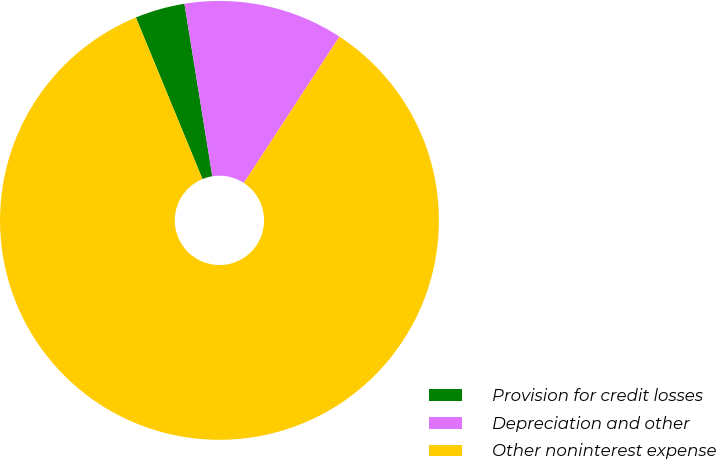Convert chart. <chart><loc_0><loc_0><loc_500><loc_500><pie_chart><fcel>Provision for credit losses<fcel>Depreciation and other<fcel>Other noninterest expense<nl><fcel>3.67%<fcel>11.76%<fcel>84.57%<nl></chart> 